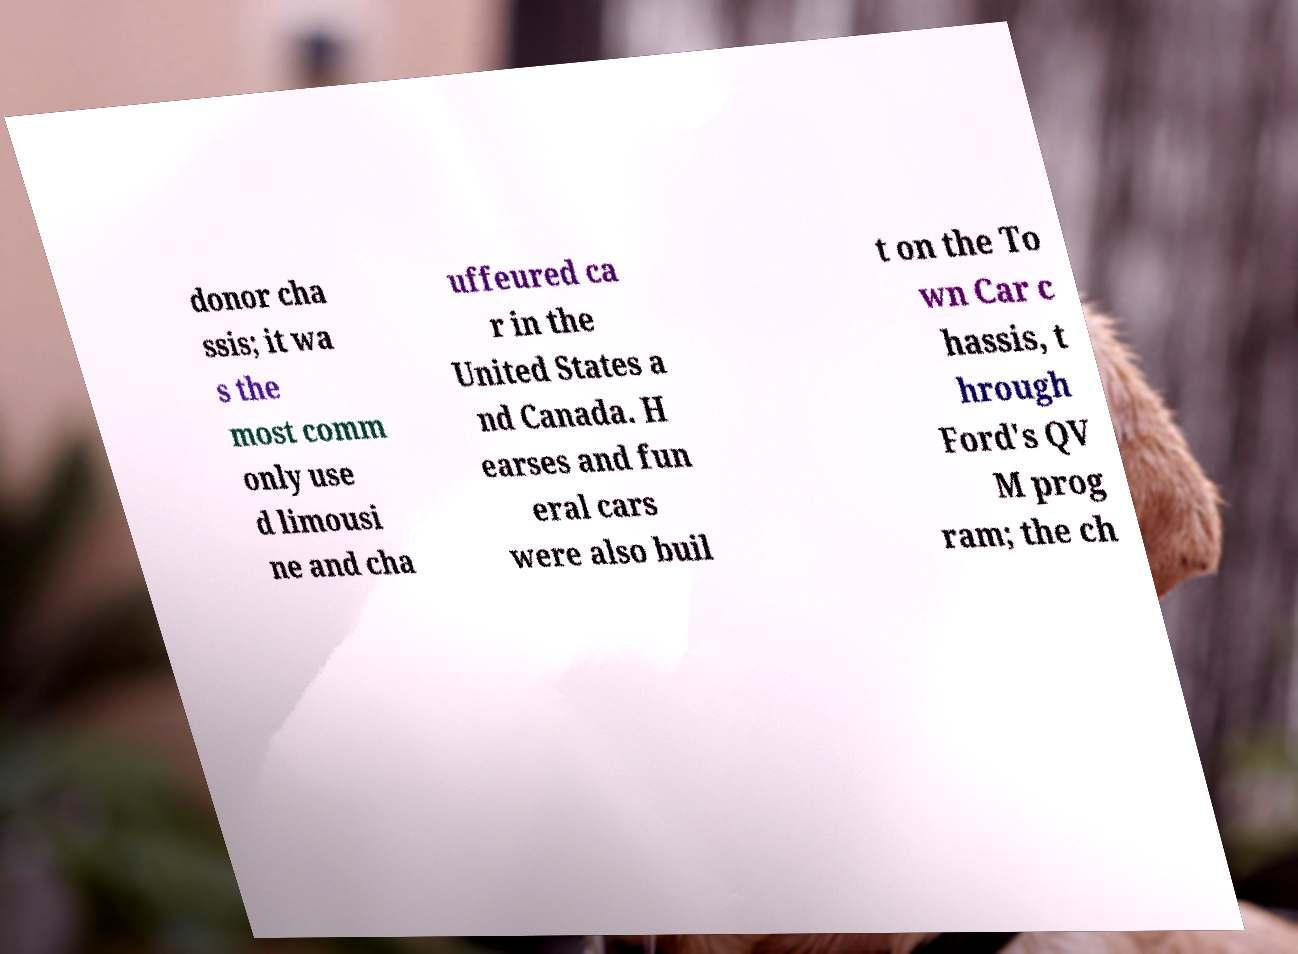Could you extract and type out the text from this image? donor cha ssis; it wa s the most comm only use d limousi ne and cha uffeured ca r in the United States a nd Canada. H earses and fun eral cars were also buil t on the To wn Car c hassis, t hrough Ford's QV M prog ram; the ch 